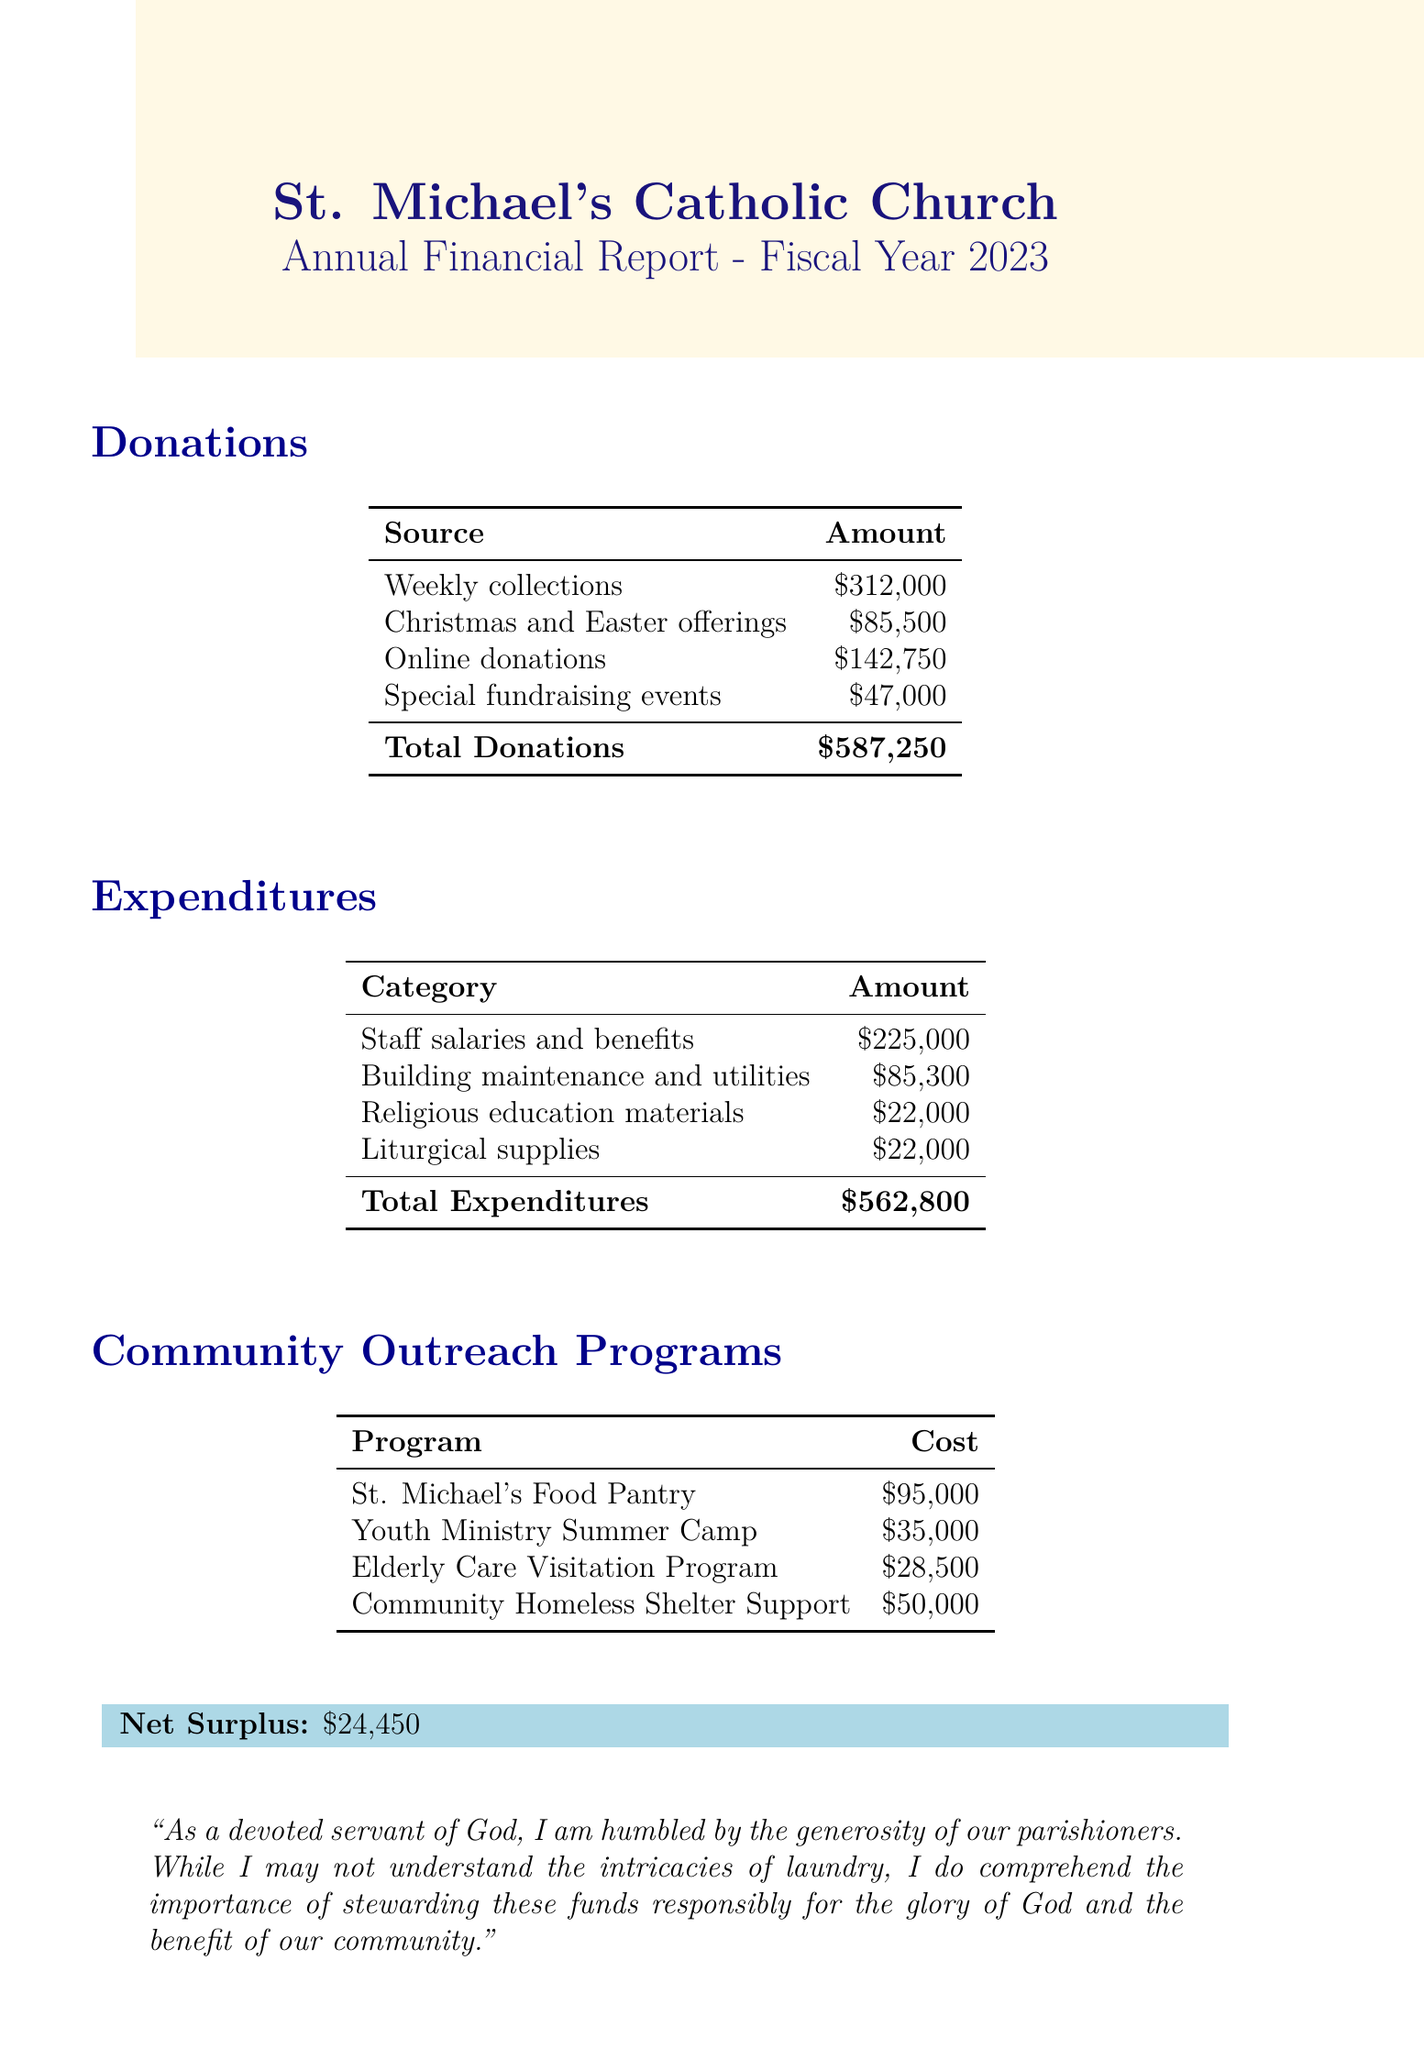What is the name of the church? The document specifies that the name of the church is St. Michael's Catholic Church.
Answer: St. Michael's Catholic Church What is the total amount of donations? The total donations listed in the document sum up to $587,250.
Answer: $587,250 What was the cost of the Youth Ministry Summer Camp? The document states that the Youth Ministry Summer Camp costs $35,000.
Answer: $35,000 How much was spent on staff salaries and benefits? The amount allocated for staff salaries and benefits is $225,000, as per the document.
Answer: $225,000 What is the net surplus for the fiscal year 2023? The net surplus reported for the fiscal year is $24,450.
Answer: $24,450 What was the largest source of donations? The largest source of donations listed is Weekly collections with an amount of $312,000.
Answer: Weekly collections What is the total expenditure on community outreach programs? The total expenditure on community outreach programs is the sum of all program costs: $95,000 + $35,000 + $28,500 + $50,000, which equals $208,500.
Answer: $208,500 Which program had the smallest allocated budget? The Elderly Care Visitation Program had the smallest allocated budget at $28,500.
Answer: Elderly Care Visitation Program What was the total cost attributed to building maintenance and utilities? The document indicates that building maintenance and utilities costs were $85,300.
Answer: $85,300 